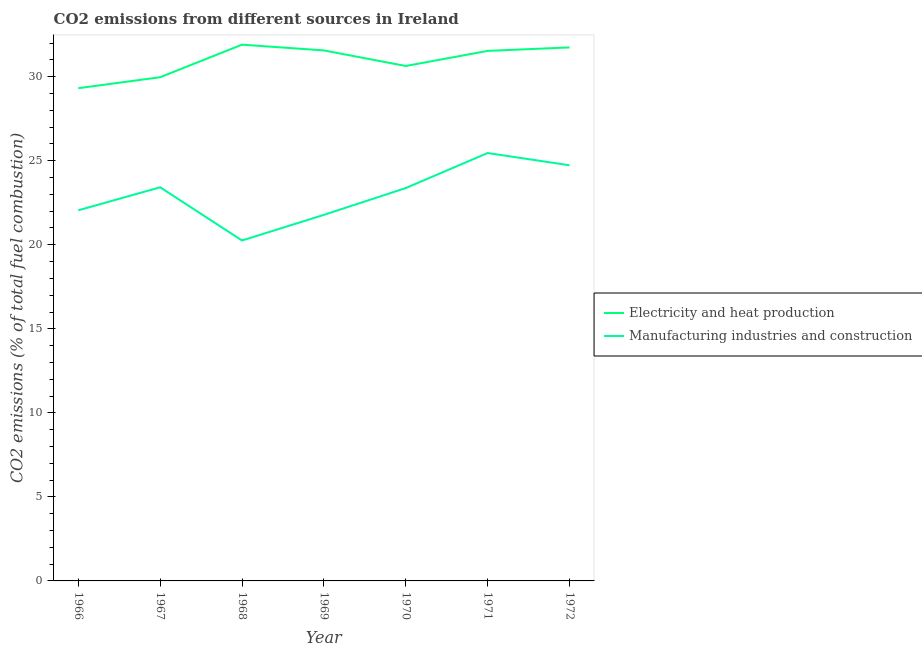How many different coloured lines are there?
Provide a short and direct response. 2. Does the line corresponding to co2 emissions due to manufacturing industries intersect with the line corresponding to co2 emissions due to electricity and heat production?
Your answer should be very brief. No. Is the number of lines equal to the number of legend labels?
Make the answer very short. Yes. What is the co2 emissions due to electricity and heat production in 1972?
Ensure brevity in your answer.  31.74. Across all years, what is the maximum co2 emissions due to electricity and heat production?
Keep it short and to the point. 31.91. Across all years, what is the minimum co2 emissions due to manufacturing industries?
Provide a succinct answer. 20.26. In which year was the co2 emissions due to manufacturing industries minimum?
Your response must be concise. 1968. What is the total co2 emissions due to electricity and heat production in the graph?
Keep it short and to the point. 216.68. What is the difference between the co2 emissions due to manufacturing industries in 1968 and that in 1969?
Offer a terse response. -1.53. What is the difference between the co2 emissions due to manufacturing industries in 1969 and the co2 emissions due to electricity and heat production in 1967?
Make the answer very short. -8.19. What is the average co2 emissions due to manufacturing industries per year?
Your answer should be very brief. 23.01. In the year 1971, what is the difference between the co2 emissions due to manufacturing industries and co2 emissions due to electricity and heat production?
Ensure brevity in your answer.  -6.08. What is the ratio of the co2 emissions due to electricity and heat production in 1966 to that in 1970?
Provide a short and direct response. 0.96. Is the difference between the co2 emissions due to electricity and heat production in 1966 and 1969 greater than the difference between the co2 emissions due to manufacturing industries in 1966 and 1969?
Give a very brief answer. No. What is the difference between the highest and the second highest co2 emissions due to manufacturing industries?
Offer a very short reply. 0.73. What is the difference between the highest and the lowest co2 emissions due to manufacturing industries?
Your answer should be very brief. 5.2. Is the sum of the co2 emissions due to electricity and heat production in 1967 and 1970 greater than the maximum co2 emissions due to manufacturing industries across all years?
Offer a terse response. Yes. Does the co2 emissions due to electricity and heat production monotonically increase over the years?
Provide a succinct answer. No. How many lines are there?
Provide a short and direct response. 2. How many years are there in the graph?
Your response must be concise. 7. What is the difference between two consecutive major ticks on the Y-axis?
Offer a terse response. 5. Are the values on the major ticks of Y-axis written in scientific E-notation?
Your answer should be very brief. No. Does the graph contain grids?
Offer a terse response. No. Where does the legend appear in the graph?
Give a very brief answer. Center right. How many legend labels are there?
Make the answer very short. 2. What is the title of the graph?
Provide a short and direct response. CO2 emissions from different sources in Ireland. Does "DAC donors" appear as one of the legend labels in the graph?
Your response must be concise. No. What is the label or title of the X-axis?
Make the answer very short. Year. What is the label or title of the Y-axis?
Provide a succinct answer. CO2 emissions (% of total fuel combustion). What is the CO2 emissions (% of total fuel combustion) of Electricity and heat production in 1966?
Provide a short and direct response. 29.32. What is the CO2 emissions (% of total fuel combustion) of Manufacturing industries and construction in 1966?
Offer a terse response. 22.05. What is the CO2 emissions (% of total fuel combustion) in Electricity and heat production in 1967?
Give a very brief answer. 29.97. What is the CO2 emissions (% of total fuel combustion) of Manufacturing industries and construction in 1967?
Give a very brief answer. 23.42. What is the CO2 emissions (% of total fuel combustion) in Electricity and heat production in 1968?
Your answer should be compact. 31.91. What is the CO2 emissions (% of total fuel combustion) of Manufacturing industries and construction in 1968?
Offer a very short reply. 20.26. What is the CO2 emissions (% of total fuel combustion) of Electricity and heat production in 1969?
Your answer should be compact. 31.57. What is the CO2 emissions (% of total fuel combustion) in Manufacturing industries and construction in 1969?
Offer a terse response. 21.78. What is the CO2 emissions (% of total fuel combustion) of Electricity and heat production in 1970?
Your answer should be very brief. 30.64. What is the CO2 emissions (% of total fuel combustion) in Manufacturing industries and construction in 1970?
Ensure brevity in your answer.  23.38. What is the CO2 emissions (% of total fuel combustion) in Electricity and heat production in 1971?
Give a very brief answer. 31.54. What is the CO2 emissions (% of total fuel combustion) in Manufacturing industries and construction in 1971?
Provide a succinct answer. 25.46. What is the CO2 emissions (% of total fuel combustion) of Electricity and heat production in 1972?
Provide a succinct answer. 31.74. What is the CO2 emissions (% of total fuel combustion) in Manufacturing industries and construction in 1972?
Keep it short and to the point. 24.73. Across all years, what is the maximum CO2 emissions (% of total fuel combustion) in Electricity and heat production?
Ensure brevity in your answer.  31.91. Across all years, what is the maximum CO2 emissions (% of total fuel combustion) in Manufacturing industries and construction?
Provide a succinct answer. 25.46. Across all years, what is the minimum CO2 emissions (% of total fuel combustion) of Electricity and heat production?
Offer a very short reply. 29.32. Across all years, what is the minimum CO2 emissions (% of total fuel combustion) of Manufacturing industries and construction?
Ensure brevity in your answer.  20.26. What is the total CO2 emissions (% of total fuel combustion) in Electricity and heat production in the graph?
Offer a terse response. 216.68. What is the total CO2 emissions (% of total fuel combustion) in Manufacturing industries and construction in the graph?
Make the answer very short. 161.08. What is the difference between the CO2 emissions (% of total fuel combustion) of Electricity and heat production in 1966 and that in 1967?
Provide a succinct answer. -0.65. What is the difference between the CO2 emissions (% of total fuel combustion) in Manufacturing industries and construction in 1966 and that in 1967?
Provide a succinct answer. -1.37. What is the difference between the CO2 emissions (% of total fuel combustion) of Electricity and heat production in 1966 and that in 1968?
Offer a terse response. -2.59. What is the difference between the CO2 emissions (% of total fuel combustion) of Manufacturing industries and construction in 1966 and that in 1968?
Offer a terse response. 1.8. What is the difference between the CO2 emissions (% of total fuel combustion) of Electricity and heat production in 1966 and that in 1969?
Keep it short and to the point. -2.25. What is the difference between the CO2 emissions (% of total fuel combustion) in Manufacturing industries and construction in 1966 and that in 1969?
Give a very brief answer. 0.27. What is the difference between the CO2 emissions (% of total fuel combustion) of Electricity and heat production in 1966 and that in 1970?
Keep it short and to the point. -1.32. What is the difference between the CO2 emissions (% of total fuel combustion) in Manufacturing industries and construction in 1966 and that in 1970?
Your answer should be compact. -1.32. What is the difference between the CO2 emissions (% of total fuel combustion) in Electricity and heat production in 1966 and that in 1971?
Your answer should be compact. -2.22. What is the difference between the CO2 emissions (% of total fuel combustion) in Manufacturing industries and construction in 1966 and that in 1971?
Your response must be concise. -3.41. What is the difference between the CO2 emissions (% of total fuel combustion) of Electricity and heat production in 1966 and that in 1972?
Provide a short and direct response. -2.43. What is the difference between the CO2 emissions (% of total fuel combustion) in Manufacturing industries and construction in 1966 and that in 1972?
Offer a very short reply. -2.68. What is the difference between the CO2 emissions (% of total fuel combustion) of Electricity and heat production in 1967 and that in 1968?
Make the answer very short. -1.94. What is the difference between the CO2 emissions (% of total fuel combustion) of Manufacturing industries and construction in 1967 and that in 1968?
Your answer should be compact. 3.17. What is the difference between the CO2 emissions (% of total fuel combustion) of Electricity and heat production in 1967 and that in 1969?
Ensure brevity in your answer.  -1.59. What is the difference between the CO2 emissions (% of total fuel combustion) of Manufacturing industries and construction in 1967 and that in 1969?
Give a very brief answer. 1.64. What is the difference between the CO2 emissions (% of total fuel combustion) of Electricity and heat production in 1967 and that in 1970?
Keep it short and to the point. -0.67. What is the difference between the CO2 emissions (% of total fuel combustion) of Manufacturing industries and construction in 1967 and that in 1970?
Ensure brevity in your answer.  0.05. What is the difference between the CO2 emissions (% of total fuel combustion) of Electricity and heat production in 1967 and that in 1971?
Give a very brief answer. -1.57. What is the difference between the CO2 emissions (% of total fuel combustion) in Manufacturing industries and construction in 1967 and that in 1971?
Your answer should be very brief. -2.04. What is the difference between the CO2 emissions (% of total fuel combustion) in Electricity and heat production in 1967 and that in 1972?
Provide a succinct answer. -1.77. What is the difference between the CO2 emissions (% of total fuel combustion) of Manufacturing industries and construction in 1967 and that in 1972?
Offer a very short reply. -1.31. What is the difference between the CO2 emissions (% of total fuel combustion) of Electricity and heat production in 1968 and that in 1969?
Your answer should be very brief. 0.34. What is the difference between the CO2 emissions (% of total fuel combustion) of Manufacturing industries and construction in 1968 and that in 1969?
Your response must be concise. -1.53. What is the difference between the CO2 emissions (% of total fuel combustion) of Electricity and heat production in 1968 and that in 1970?
Keep it short and to the point. 1.27. What is the difference between the CO2 emissions (% of total fuel combustion) of Manufacturing industries and construction in 1968 and that in 1970?
Keep it short and to the point. -3.12. What is the difference between the CO2 emissions (% of total fuel combustion) of Electricity and heat production in 1968 and that in 1971?
Keep it short and to the point. 0.37. What is the difference between the CO2 emissions (% of total fuel combustion) in Manufacturing industries and construction in 1968 and that in 1971?
Provide a succinct answer. -5.2. What is the difference between the CO2 emissions (% of total fuel combustion) in Electricity and heat production in 1968 and that in 1972?
Ensure brevity in your answer.  0.16. What is the difference between the CO2 emissions (% of total fuel combustion) in Manufacturing industries and construction in 1968 and that in 1972?
Offer a terse response. -4.47. What is the difference between the CO2 emissions (% of total fuel combustion) of Electricity and heat production in 1969 and that in 1970?
Ensure brevity in your answer.  0.93. What is the difference between the CO2 emissions (% of total fuel combustion) of Manufacturing industries and construction in 1969 and that in 1970?
Your answer should be very brief. -1.59. What is the difference between the CO2 emissions (% of total fuel combustion) in Electricity and heat production in 1969 and that in 1971?
Offer a very short reply. 0.03. What is the difference between the CO2 emissions (% of total fuel combustion) in Manufacturing industries and construction in 1969 and that in 1971?
Make the answer very short. -3.68. What is the difference between the CO2 emissions (% of total fuel combustion) in Electricity and heat production in 1969 and that in 1972?
Ensure brevity in your answer.  -0.18. What is the difference between the CO2 emissions (% of total fuel combustion) in Manufacturing industries and construction in 1969 and that in 1972?
Your response must be concise. -2.95. What is the difference between the CO2 emissions (% of total fuel combustion) in Electricity and heat production in 1970 and that in 1971?
Give a very brief answer. -0.9. What is the difference between the CO2 emissions (% of total fuel combustion) of Manufacturing industries and construction in 1970 and that in 1971?
Keep it short and to the point. -2.08. What is the difference between the CO2 emissions (% of total fuel combustion) in Electricity and heat production in 1970 and that in 1972?
Provide a succinct answer. -1.1. What is the difference between the CO2 emissions (% of total fuel combustion) in Manufacturing industries and construction in 1970 and that in 1972?
Your answer should be compact. -1.36. What is the difference between the CO2 emissions (% of total fuel combustion) in Electricity and heat production in 1971 and that in 1972?
Provide a succinct answer. -0.21. What is the difference between the CO2 emissions (% of total fuel combustion) of Manufacturing industries and construction in 1971 and that in 1972?
Make the answer very short. 0.73. What is the difference between the CO2 emissions (% of total fuel combustion) of Electricity and heat production in 1966 and the CO2 emissions (% of total fuel combustion) of Manufacturing industries and construction in 1967?
Offer a terse response. 5.9. What is the difference between the CO2 emissions (% of total fuel combustion) in Electricity and heat production in 1966 and the CO2 emissions (% of total fuel combustion) in Manufacturing industries and construction in 1968?
Offer a very short reply. 9.06. What is the difference between the CO2 emissions (% of total fuel combustion) in Electricity and heat production in 1966 and the CO2 emissions (% of total fuel combustion) in Manufacturing industries and construction in 1969?
Ensure brevity in your answer.  7.54. What is the difference between the CO2 emissions (% of total fuel combustion) of Electricity and heat production in 1966 and the CO2 emissions (% of total fuel combustion) of Manufacturing industries and construction in 1970?
Offer a terse response. 5.94. What is the difference between the CO2 emissions (% of total fuel combustion) of Electricity and heat production in 1966 and the CO2 emissions (% of total fuel combustion) of Manufacturing industries and construction in 1971?
Make the answer very short. 3.86. What is the difference between the CO2 emissions (% of total fuel combustion) in Electricity and heat production in 1966 and the CO2 emissions (% of total fuel combustion) in Manufacturing industries and construction in 1972?
Ensure brevity in your answer.  4.59. What is the difference between the CO2 emissions (% of total fuel combustion) in Electricity and heat production in 1967 and the CO2 emissions (% of total fuel combustion) in Manufacturing industries and construction in 1968?
Provide a succinct answer. 9.71. What is the difference between the CO2 emissions (% of total fuel combustion) in Electricity and heat production in 1967 and the CO2 emissions (% of total fuel combustion) in Manufacturing industries and construction in 1969?
Offer a very short reply. 8.19. What is the difference between the CO2 emissions (% of total fuel combustion) of Electricity and heat production in 1967 and the CO2 emissions (% of total fuel combustion) of Manufacturing industries and construction in 1970?
Ensure brevity in your answer.  6.59. What is the difference between the CO2 emissions (% of total fuel combustion) of Electricity and heat production in 1967 and the CO2 emissions (% of total fuel combustion) of Manufacturing industries and construction in 1971?
Provide a succinct answer. 4.51. What is the difference between the CO2 emissions (% of total fuel combustion) of Electricity and heat production in 1967 and the CO2 emissions (% of total fuel combustion) of Manufacturing industries and construction in 1972?
Offer a terse response. 5.24. What is the difference between the CO2 emissions (% of total fuel combustion) of Electricity and heat production in 1968 and the CO2 emissions (% of total fuel combustion) of Manufacturing industries and construction in 1969?
Keep it short and to the point. 10.13. What is the difference between the CO2 emissions (% of total fuel combustion) of Electricity and heat production in 1968 and the CO2 emissions (% of total fuel combustion) of Manufacturing industries and construction in 1970?
Keep it short and to the point. 8.53. What is the difference between the CO2 emissions (% of total fuel combustion) in Electricity and heat production in 1968 and the CO2 emissions (% of total fuel combustion) in Manufacturing industries and construction in 1971?
Make the answer very short. 6.45. What is the difference between the CO2 emissions (% of total fuel combustion) of Electricity and heat production in 1968 and the CO2 emissions (% of total fuel combustion) of Manufacturing industries and construction in 1972?
Make the answer very short. 7.18. What is the difference between the CO2 emissions (% of total fuel combustion) of Electricity and heat production in 1969 and the CO2 emissions (% of total fuel combustion) of Manufacturing industries and construction in 1970?
Your answer should be compact. 8.19. What is the difference between the CO2 emissions (% of total fuel combustion) in Electricity and heat production in 1969 and the CO2 emissions (% of total fuel combustion) in Manufacturing industries and construction in 1971?
Your answer should be very brief. 6.11. What is the difference between the CO2 emissions (% of total fuel combustion) in Electricity and heat production in 1969 and the CO2 emissions (% of total fuel combustion) in Manufacturing industries and construction in 1972?
Offer a terse response. 6.83. What is the difference between the CO2 emissions (% of total fuel combustion) of Electricity and heat production in 1970 and the CO2 emissions (% of total fuel combustion) of Manufacturing industries and construction in 1971?
Offer a terse response. 5.18. What is the difference between the CO2 emissions (% of total fuel combustion) of Electricity and heat production in 1970 and the CO2 emissions (% of total fuel combustion) of Manufacturing industries and construction in 1972?
Ensure brevity in your answer.  5.91. What is the difference between the CO2 emissions (% of total fuel combustion) in Electricity and heat production in 1971 and the CO2 emissions (% of total fuel combustion) in Manufacturing industries and construction in 1972?
Keep it short and to the point. 6.81. What is the average CO2 emissions (% of total fuel combustion) in Electricity and heat production per year?
Keep it short and to the point. 30.95. What is the average CO2 emissions (% of total fuel combustion) in Manufacturing industries and construction per year?
Give a very brief answer. 23.01. In the year 1966, what is the difference between the CO2 emissions (% of total fuel combustion) of Electricity and heat production and CO2 emissions (% of total fuel combustion) of Manufacturing industries and construction?
Your answer should be compact. 7.27. In the year 1967, what is the difference between the CO2 emissions (% of total fuel combustion) of Electricity and heat production and CO2 emissions (% of total fuel combustion) of Manufacturing industries and construction?
Keep it short and to the point. 6.55. In the year 1968, what is the difference between the CO2 emissions (% of total fuel combustion) in Electricity and heat production and CO2 emissions (% of total fuel combustion) in Manufacturing industries and construction?
Your response must be concise. 11.65. In the year 1969, what is the difference between the CO2 emissions (% of total fuel combustion) of Electricity and heat production and CO2 emissions (% of total fuel combustion) of Manufacturing industries and construction?
Provide a short and direct response. 9.78. In the year 1970, what is the difference between the CO2 emissions (% of total fuel combustion) of Electricity and heat production and CO2 emissions (% of total fuel combustion) of Manufacturing industries and construction?
Your answer should be compact. 7.26. In the year 1971, what is the difference between the CO2 emissions (% of total fuel combustion) of Electricity and heat production and CO2 emissions (% of total fuel combustion) of Manufacturing industries and construction?
Your answer should be compact. 6.08. In the year 1972, what is the difference between the CO2 emissions (% of total fuel combustion) in Electricity and heat production and CO2 emissions (% of total fuel combustion) in Manufacturing industries and construction?
Offer a very short reply. 7.01. What is the ratio of the CO2 emissions (% of total fuel combustion) in Electricity and heat production in 1966 to that in 1967?
Give a very brief answer. 0.98. What is the ratio of the CO2 emissions (% of total fuel combustion) of Manufacturing industries and construction in 1966 to that in 1967?
Give a very brief answer. 0.94. What is the ratio of the CO2 emissions (% of total fuel combustion) in Electricity and heat production in 1966 to that in 1968?
Give a very brief answer. 0.92. What is the ratio of the CO2 emissions (% of total fuel combustion) in Manufacturing industries and construction in 1966 to that in 1968?
Make the answer very short. 1.09. What is the ratio of the CO2 emissions (% of total fuel combustion) of Electricity and heat production in 1966 to that in 1969?
Give a very brief answer. 0.93. What is the ratio of the CO2 emissions (% of total fuel combustion) in Manufacturing industries and construction in 1966 to that in 1969?
Offer a very short reply. 1.01. What is the ratio of the CO2 emissions (% of total fuel combustion) of Electricity and heat production in 1966 to that in 1970?
Offer a very short reply. 0.96. What is the ratio of the CO2 emissions (% of total fuel combustion) in Manufacturing industries and construction in 1966 to that in 1970?
Your answer should be compact. 0.94. What is the ratio of the CO2 emissions (% of total fuel combustion) in Electricity and heat production in 1966 to that in 1971?
Your answer should be very brief. 0.93. What is the ratio of the CO2 emissions (% of total fuel combustion) of Manufacturing industries and construction in 1966 to that in 1971?
Provide a succinct answer. 0.87. What is the ratio of the CO2 emissions (% of total fuel combustion) in Electricity and heat production in 1966 to that in 1972?
Keep it short and to the point. 0.92. What is the ratio of the CO2 emissions (% of total fuel combustion) in Manufacturing industries and construction in 1966 to that in 1972?
Give a very brief answer. 0.89. What is the ratio of the CO2 emissions (% of total fuel combustion) of Electricity and heat production in 1967 to that in 1968?
Your answer should be compact. 0.94. What is the ratio of the CO2 emissions (% of total fuel combustion) of Manufacturing industries and construction in 1967 to that in 1968?
Your answer should be very brief. 1.16. What is the ratio of the CO2 emissions (% of total fuel combustion) of Electricity and heat production in 1967 to that in 1969?
Offer a terse response. 0.95. What is the ratio of the CO2 emissions (% of total fuel combustion) in Manufacturing industries and construction in 1967 to that in 1969?
Your answer should be very brief. 1.08. What is the ratio of the CO2 emissions (% of total fuel combustion) of Electricity and heat production in 1967 to that in 1970?
Make the answer very short. 0.98. What is the ratio of the CO2 emissions (% of total fuel combustion) of Electricity and heat production in 1967 to that in 1971?
Your answer should be very brief. 0.95. What is the ratio of the CO2 emissions (% of total fuel combustion) of Manufacturing industries and construction in 1967 to that in 1971?
Provide a succinct answer. 0.92. What is the ratio of the CO2 emissions (% of total fuel combustion) of Electricity and heat production in 1967 to that in 1972?
Make the answer very short. 0.94. What is the ratio of the CO2 emissions (% of total fuel combustion) in Manufacturing industries and construction in 1967 to that in 1972?
Ensure brevity in your answer.  0.95. What is the ratio of the CO2 emissions (% of total fuel combustion) of Electricity and heat production in 1968 to that in 1969?
Ensure brevity in your answer.  1.01. What is the ratio of the CO2 emissions (% of total fuel combustion) in Manufacturing industries and construction in 1968 to that in 1969?
Provide a succinct answer. 0.93. What is the ratio of the CO2 emissions (% of total fuel combustion) of Electricity and heat production in 1968 to that in 1970?
Offer a terse response. 1.04. What is the ratio of the CO2 emissions (% of total fuel combustion) of Manufacturing industries and construction in 1968 to that in 1970?
Your answer should be very brief. 0.87. What is the ratio of the CO2 emissions (% of total fuel combustion) in Electricity and heat production in 1968 to that in 1971?
Provide a succinct answer. 1.01. What is the ratio of the CO2 emissions (% of total fuel combustion) of Manufacturing industries and construction in 1968 to that in 1971?
Ensure brevity in your answer.  0.8. What is the ratio of the CO2 emissions (% of total fuel combustion) of Manufacturing industries and construction in 1968 to that in 1972?
Your answer should be compact. 0.82. What is the ratio of the CO2 emissions (% of total fuel combustion) of Electricity and heat production in 1969 to that in 1970?
Your answer should be very brief. 1.03. What is the ratio of the CO2 emissions (% of total fuel combustion) in Manufacturing industries and construction in 1969 to that in 1970?
Offer a very short reply. 0.93. What is the ratio of the CO2 emissions (% of total fuel combustion) of Electricity and heat production in 1969 to that in 1971?
Make the answer very short. 1. What is the ratio of the CO2 emissions (% of total fuel combustion) of Manufacturing industries and construction in 1969 to that in 1971?
Your answer should be very brief. 0.86. What is the ratio of the CO2 emissions (% of total fuel combustion) in Electricity and heat production in 1969 to that in 1972?
Your response must be concise. 0.99. What is the ratio of the CO2 emissions (% of total fuel combustion) in Manufacturing industries and construction in 1969 to that in 1972?
Offer a very short reply. 0.88. What is the ratio of the CO2 emissions (% of total fuel combustion) of Electricity and heat production in 1970 to that in 1971?
Provide a short and direct response. 0.97. What is the ratio of the CO2 emissions (% of total fuel combustion) of Manufacturing industries and construction in 1970 to that in 1971?
Provide a succinct answer. 0.92. What is the ratio of the CO2 emissions (% of total fuel combustion) in Electricity and heat production in 1970 to that in 1972?
Keep it short and to the point. 0.97. What is the ratio of the CO2 emissions (% of total fuel combustion) in Manufacturing industries and construction in 1970 to that in 1972?
Your answer should be compact. 0.95. What is the ratio of the CO2 emissions (% of total fuel combustion) of Manufacturing industries and construction in 1971 to that in 1972?
Offer a very short reply. 1.03. What is the difference between the highest and the second highest CO2 emissions (% of total fuel combustion) of Electricity and heat production?
Your answer should be very brief. 0.16. What is the difference between the highest and the second highest CO2 emissions (% of total fuel combustion) of Manufacturing industries and construction?
Provide a short and direct response. 0.73. What is the difference between the highest and the lowest CO2 emissions (% of total fuel combustion) in Electricity and heat production?
Keep it short and to the point. 2.59. What is the difference between the highest and the lowest CO2 emissions (% of total fuel combustion) of Manufacturing industries and construction?
Offer a very short reply. 5.2. 